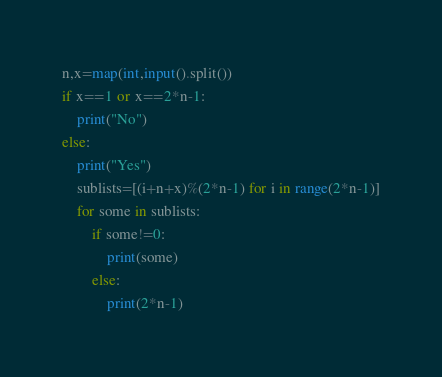Convert code to text. <code><loc_0><loc_0><loc_500><loc_500><_Python_>n,x=map(int,input().split())
if x==1 or x==2*n-1:
    print("No")
else:
    print("Yes")
    sublists=[(i+n+x)%(2*n-1) for i in range(2*n-1)]
    for some in sublists:
        if some!=0:
            print(some)
        else:
            print(2*n-1)</code> 